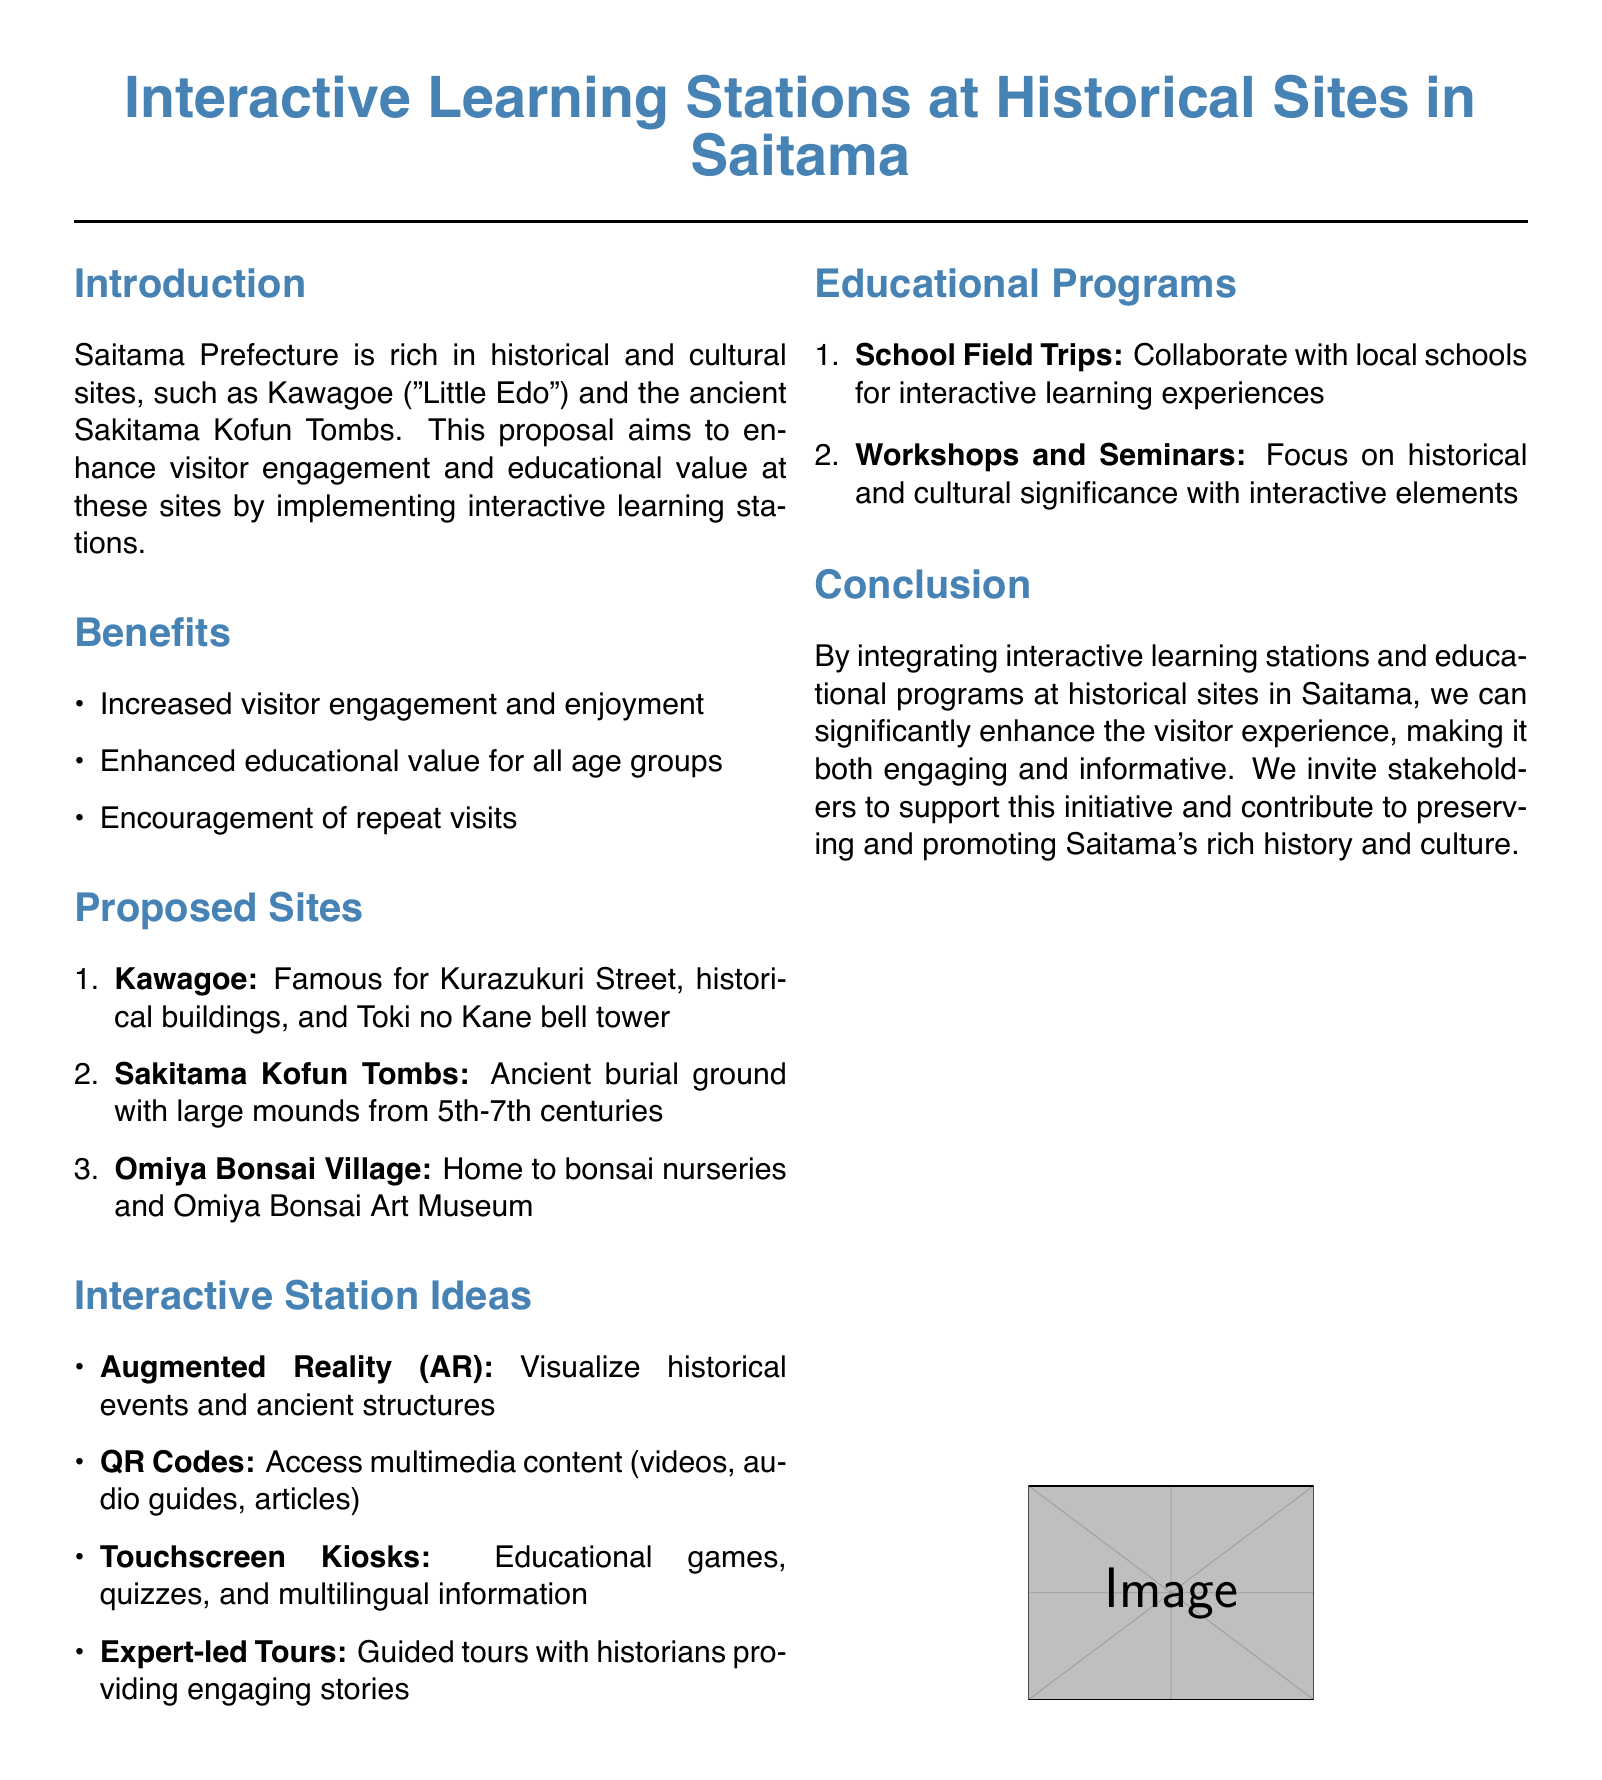What is the name of the proposal? The proposal is titled "Implementing Interactive Learning Stations at Historical Sites in Saitama: A Proposal for Enhancing Visitor Engagement and Educational Value."
Answer: Interactive Learning Stations at Historical Sites in Saitama Which historical site is referred to as "Little Edo"? The document mentions Kawagoe as "Little Edo."
Answer: Kawagoe What technology is suggested for visualizing historical events? The proposal suggests using Augmented Reality (AR) for visualizing historical events.
Answer: Augmented Reality (AR) How many proposed sites are listed in the document? The document lists three proposed sites.
Answer: 3 What age group is the educational value enhanced for? The proposal states that educational value is enhanced for all age groups.
Answer: All age groups What type of tours are suggested for visitor engagement? The document suggests expert-led tours for visitor engagement.
Answer: Expert-led Tours What collaboration is proposed for school field trips? The proposal mentions collaborating with local schools for interactive learning experiences.
Answer: Local schools What is one of the interactive station ideas mentioned? The document includes QR Codes as one of the interactive station ideas.
Answer: QR Codes What does the proposal aim to enhance at historical sites? The main aim is to enhance visitor engagement and educational value at the historical sites.
Answer: Visitor engagement and educational value 